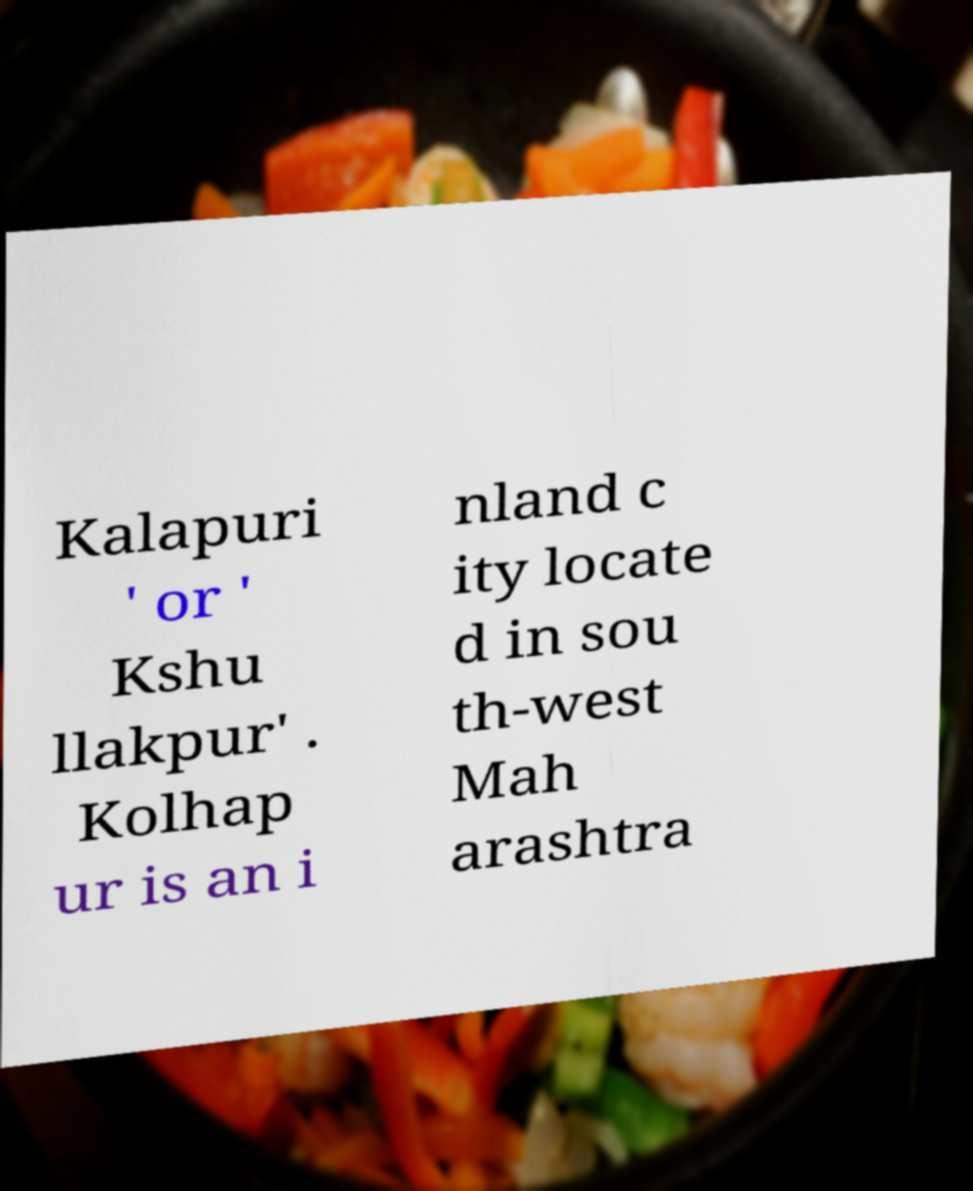For documentation purposes, I need the text within this image transcribed. Could you provide that? Kalapuri ' or ' Kshu llakpur' . Kolhap ur is an i nland c ity locate d in sou th-west Mah arashtra 